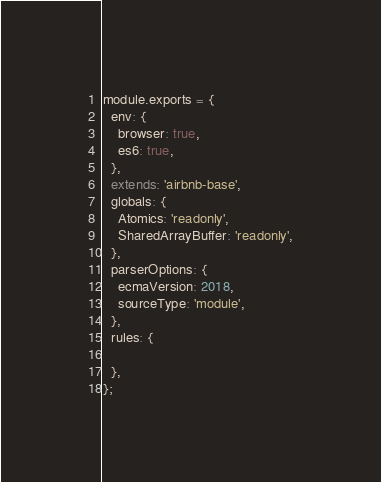<code> <loc_0><loc_0><loc_500><loc_500><_JavaScript_>module.exports = {
  env: {
    browser: true,
    es6: true,
  },
  extends: 'airbnb-base',
  globals: {
    Atomics: 'readonly',
    SharedArrayBuffer: 'readonly',
  },
  parserOptions: {
    ecmaVersion: 2018,
    sourceType: 'module',
  },
  rules: {

  },
};
</code> 